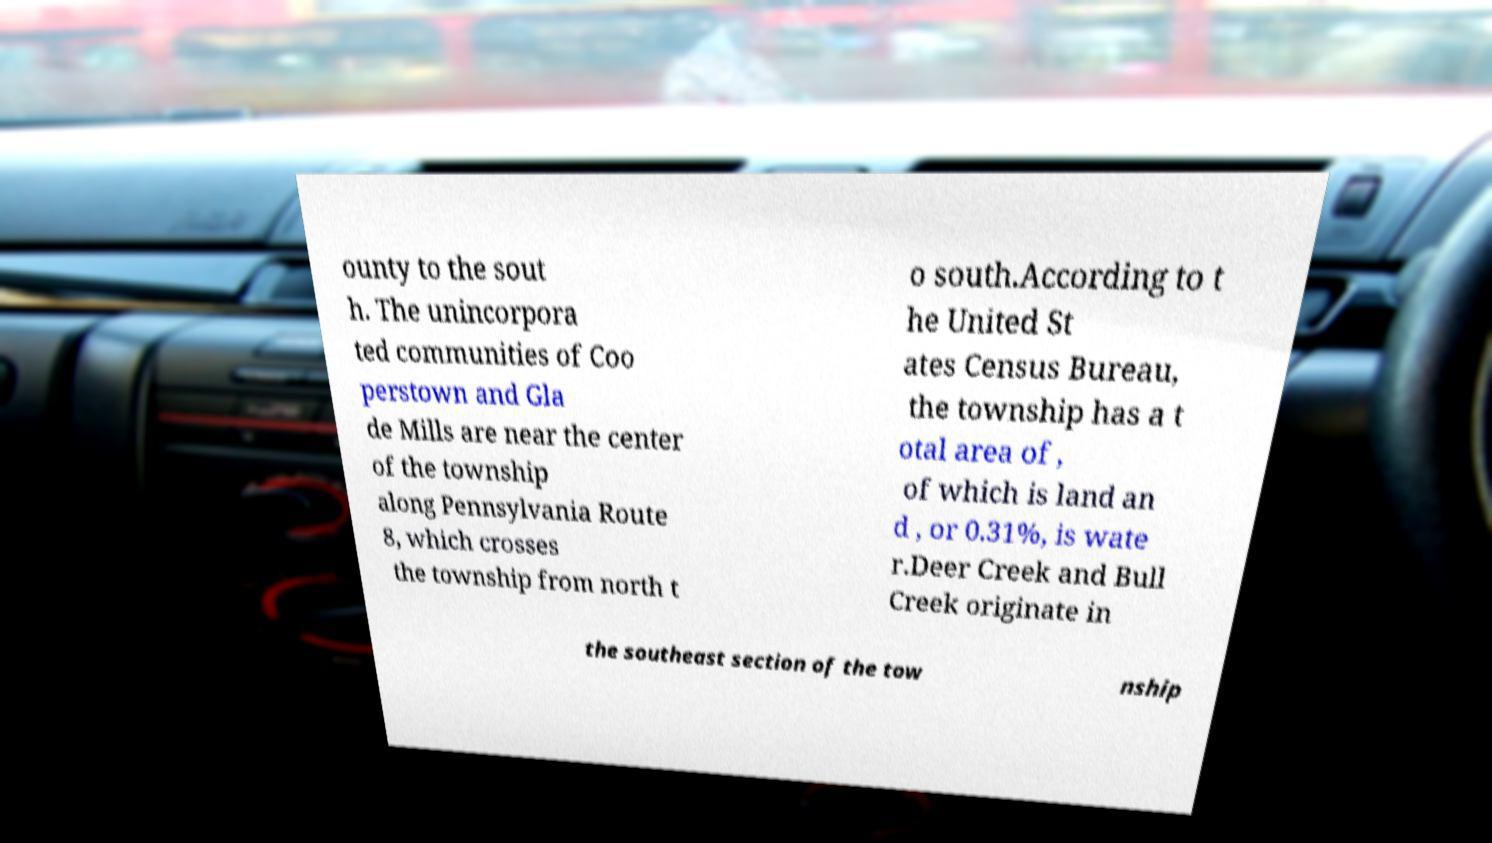Could you extract and type out the text from this image? ounty to the sout h. The unincorpora ted communities of Coo perstown and Gla de Mills are near the center of the township along Pennsylvania Route 8, which crosses the township from north t o south.According to t he United St ates Census Bureau, the township has a t otal area of , of which is land an d , or 0.31%, is wate r.Deer Creek and Bull Creek originate in the southeast section of the tow nship 